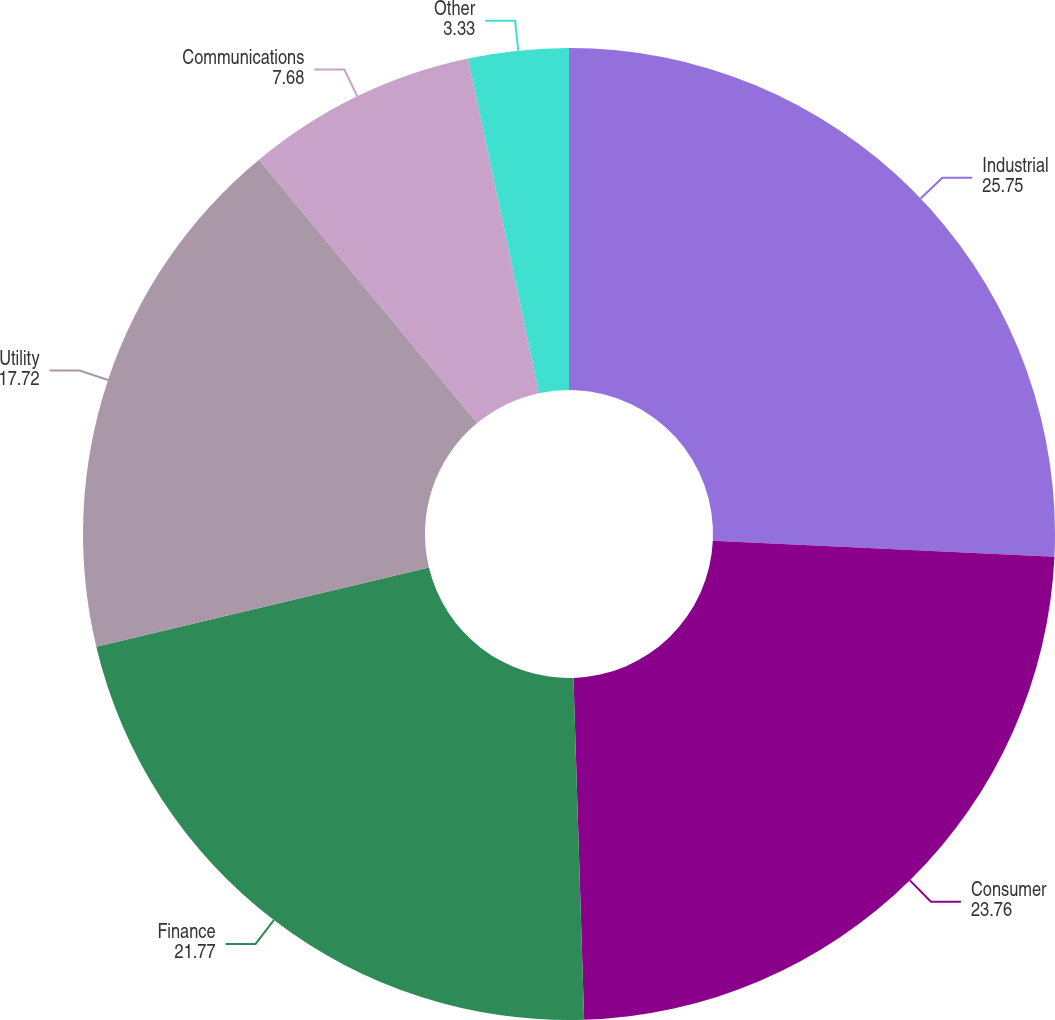Convert chart to OTSL. <chart><loc_0><loc_0><loc_500><loc_500><pie_chart><fcel>Industrial<fcel>Consumer<fcel>Finance<fcel>Utility<fcel>Communications<fcel>Other<nl><fcel>25.75%<fcel>23.76%<fcel>21.77%<fcel>17.72%<fcel>7.68%<fcel>3.33%<nl></chart> 